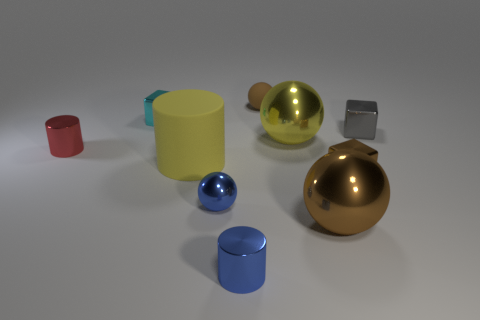What shape is the yellow metallic thing that is the same size as the yellow matte object?
Offer a terse response. Sphere. What shape is the tiny object that is the same color as the rubber sphere?
Make the answer very short. Cube. Are there the same number of large spheres in front of the gray metallic cube and large yellow things?
Ensure brevity in your answer.  Yes. The brown thing behind the matte thing that is on the left side of the shiny cylinder that is in front of the tiny brown metallic object is made of what material?
Keep it short and to the point. Rubber. There is a object that is made of the same material as the tiny brown ball; what is its shape?
Your answer should be compact. Cylinder. What number of blue metallic things are right of the metallic object to the left of the small block on the left side of the tiny matte sphere?
Offer a terse response. 2. How many brown objects are tiny metal cubes or tiny objects?
Offer a terse response. 2. There is a brown cube; is its size the same as the brown ball in front of the red object?
Provide a succinct answer. No. What material is the other yellow thing that is the same shape as the small matte object?
Your answer should be very brief. Metal. What number of other objects are the same size as the brown metal cube?
Keep it short and to the point. 6. 